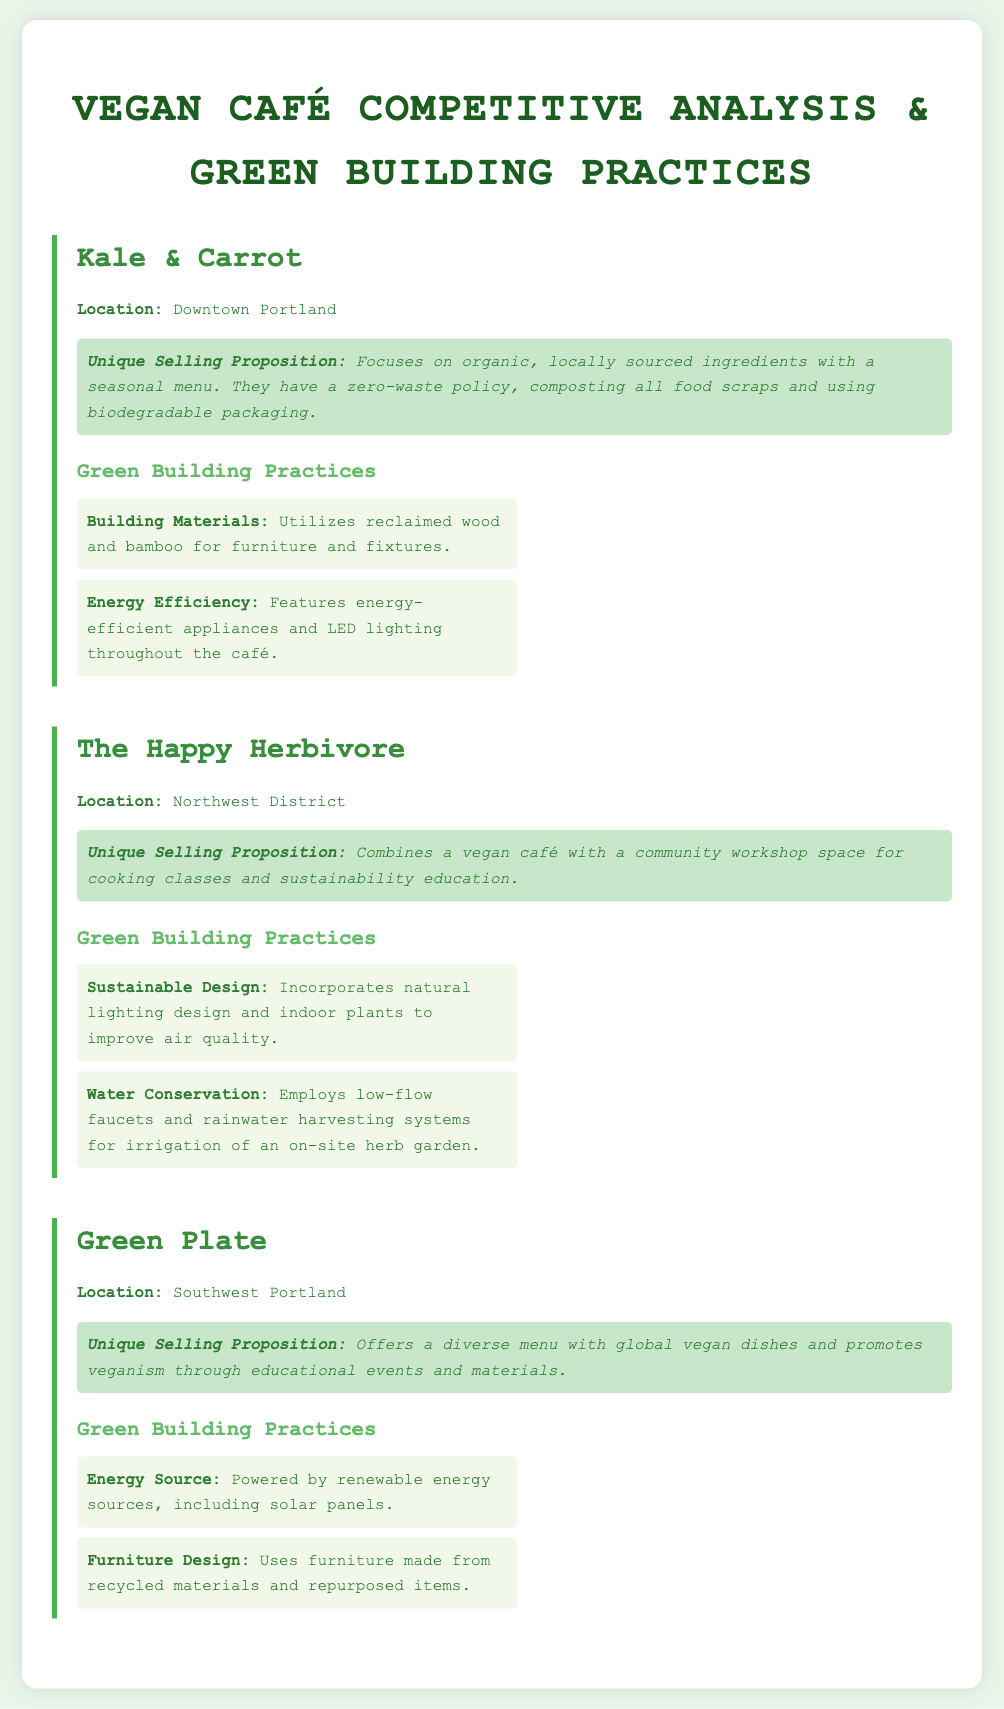What is the location of Kale & Carrot? Kale & Carrot is located in Downtown Portland.
Answer: Downtown Portland What is the unique selling proposition of The Happy Herbivore? The Happy Herbivore combines a vegan café with a community workshop space for cooking classes and sustainability education.
Answer: Community workshop space What sustainable design practice is employed by The Happy Herbivore? The Happy Herbivore incorporates natural lighting design and indoor plants to improve air quality.
Answer: Natural lighting design Which café is powered by renewable energy sources? Green Plate is powered by renewable energy sources, including solar panels.
Answer: Green Plate What type of faucet does The Happy Herbivore use for water conservation? The Happy Herbivore employs low-flow faucets for water conservation.
Answer: Low-flow faucets What building material does Kale & Carrot use for furniture? Kale & Carrot utilizes reclaimed wood and bamboo for furniture and fixtures.
Answer: Reclaimed wood and bamboo What is a distinguishing feature of Green Plate's menu? Green Plate offers a diverse menu with global vegan dishes.
Answer: Global vegan dishes How many cafés are analyzed in the document? The document analyzes three cafes.
Answer: Three What practice does Green Plate use for furniture design? Green Plate uses furniture made from recycled materials and repurposed items.
Answer: Recycled materials 